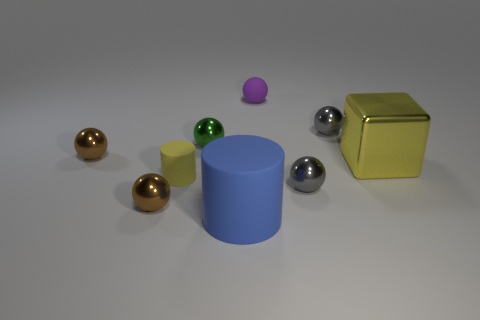Subtract all tiny brown balls. How many balls are left? 4 Subtract all blocks. How many objects are left? 8 Add 9 large yellow shiny blocks. How many large yellow shiny blocks exist? 10 Add 1 large brown cylinders. How many objects exist? 10 Subtract all yellow cylinders. How many cylinders are left? 1 Subtract 0 brown cylinders. How many objects are left? 9 Subtract 1 spheres. How many spheres are left? 5 Subtract all yellow cylinders. Subtract all brown cubes. How many cylinders are left? 1 Subtract all purple spheres. How many blue cylinders are left? 1 Subtract all big cyan metallic things. Subtract all yellow shiny objects. How many objects are left? 8 